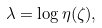Convert formula to latex. <formula><loc_0><loc_0><loc_500><loc_500>\lambda & = \log \eta ( \zeta ) ,</formula> 